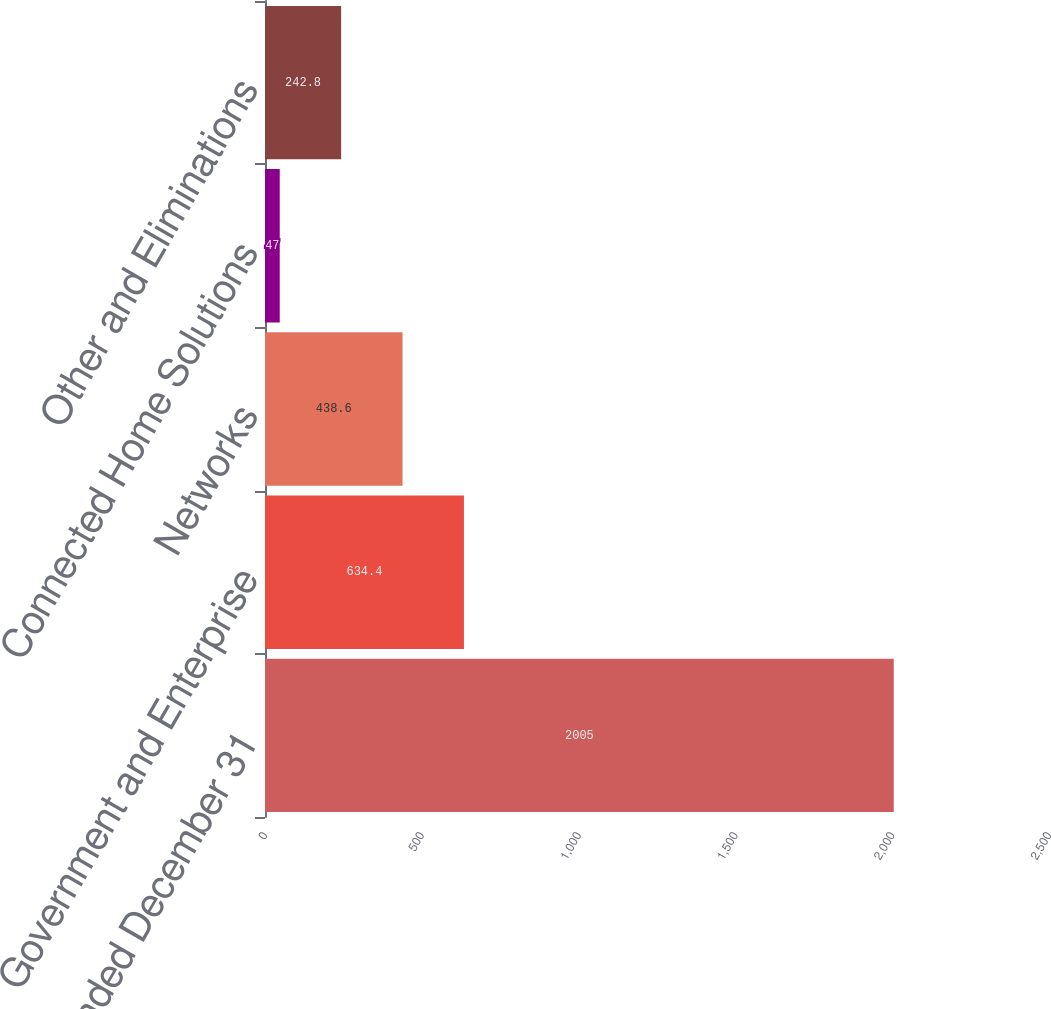Convert chart. <chart><loc_0><loc_0><loc_500><loc_500><bar_chart><fcel>Years Ended December 31<fcel>Government and Enterprise<fcel>Networks<fcel>Connected Home Solutions<fcel>Other and Eliminations<nl><fcel>2005<fcel>634.4<fcel>438.6<fcel>47<fcel>242.8<nl></chart> 